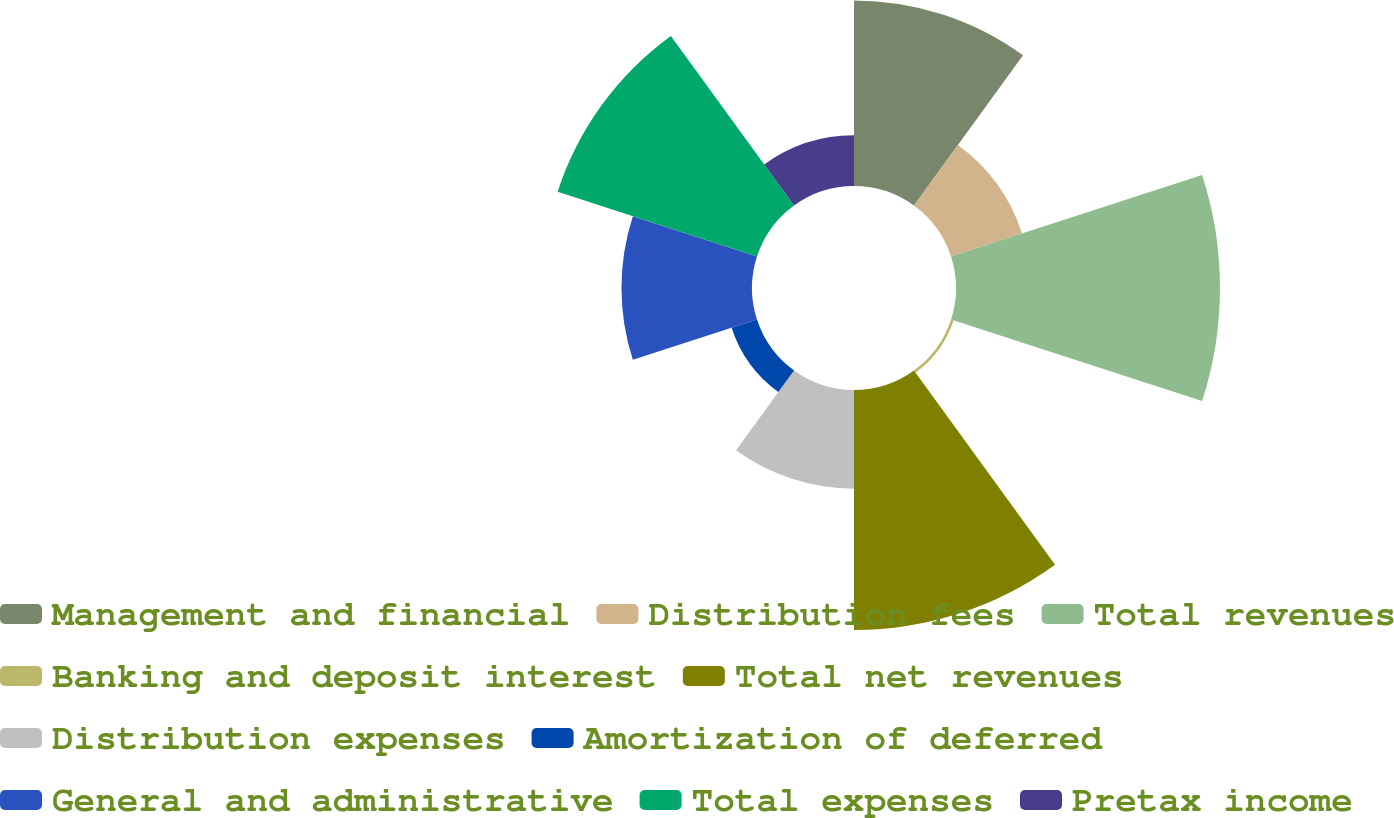Convert chart to OTSL. <chart><loc_0><loc_0><loc_500><loc_500><pie_chart><fcel>Management and financial<fcel>Distribution fees<fcel>Total revenues<fcel>Banking and deposit interest<fcel>Total net revenues<fcel>Distribution expenses<fcel>Amortization of deferred<fcel>General and administrative<fcel>Total expenses<fcel>Pretax income<nl><fcel>14.46%<fcel>5.82%<fcel>20.57%<fcel>0.21%<fcel>18.7%<fcel>7.69%<fcel>2.08%<fcel>10.17%<fcel>16.33%<fcel>3.95%<nl></chart> 